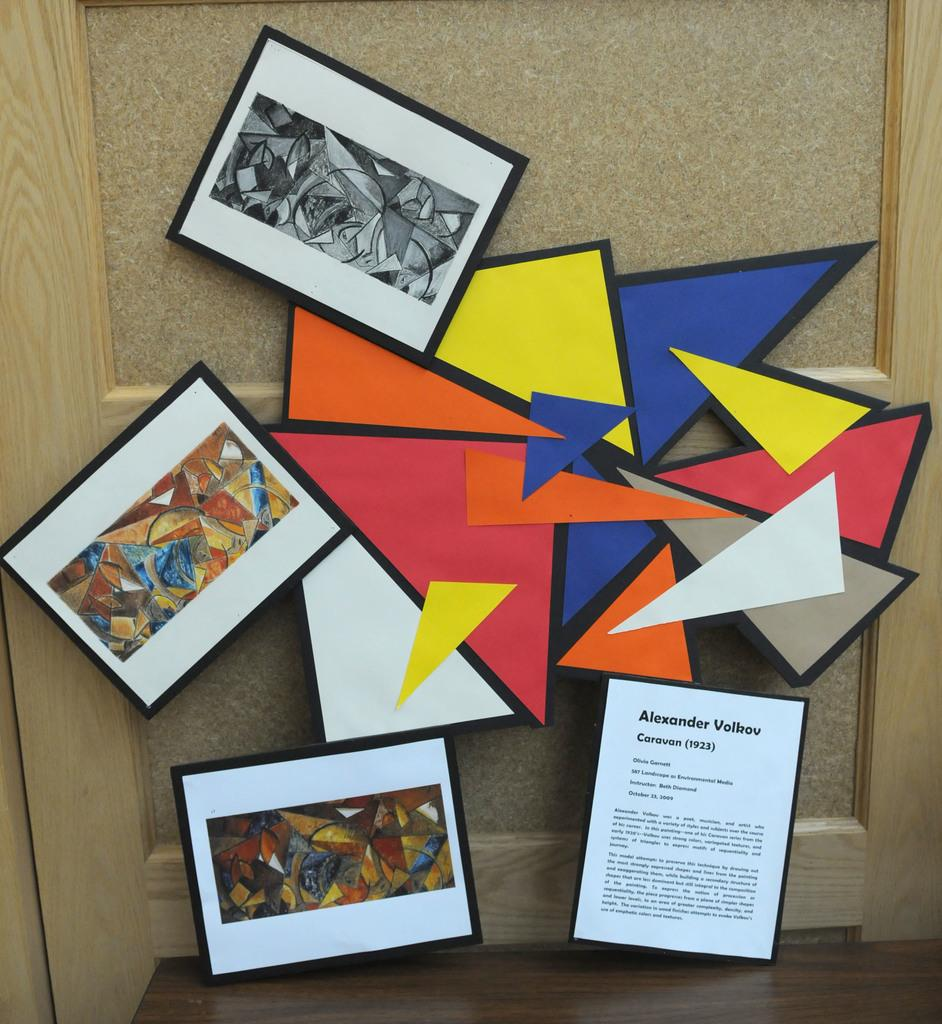What can be seen on the wall in the image? There is a wall with photo frames in the image. Can you describe any other objects present in the image? Unfortunately, the provided facts only mention the wall with photo frames. However, we can infer that there are other objects present in the image, as it is mentioned that there are "other objects" present. How many cattle can be seen grazing in the image? There are no cattle present in the image; it only features a wall with photo frames and other unspecified objects. What type of pie is being served in the image? There is no pie present in the image; it only features a wall with photo frames and other unspecified objects. 